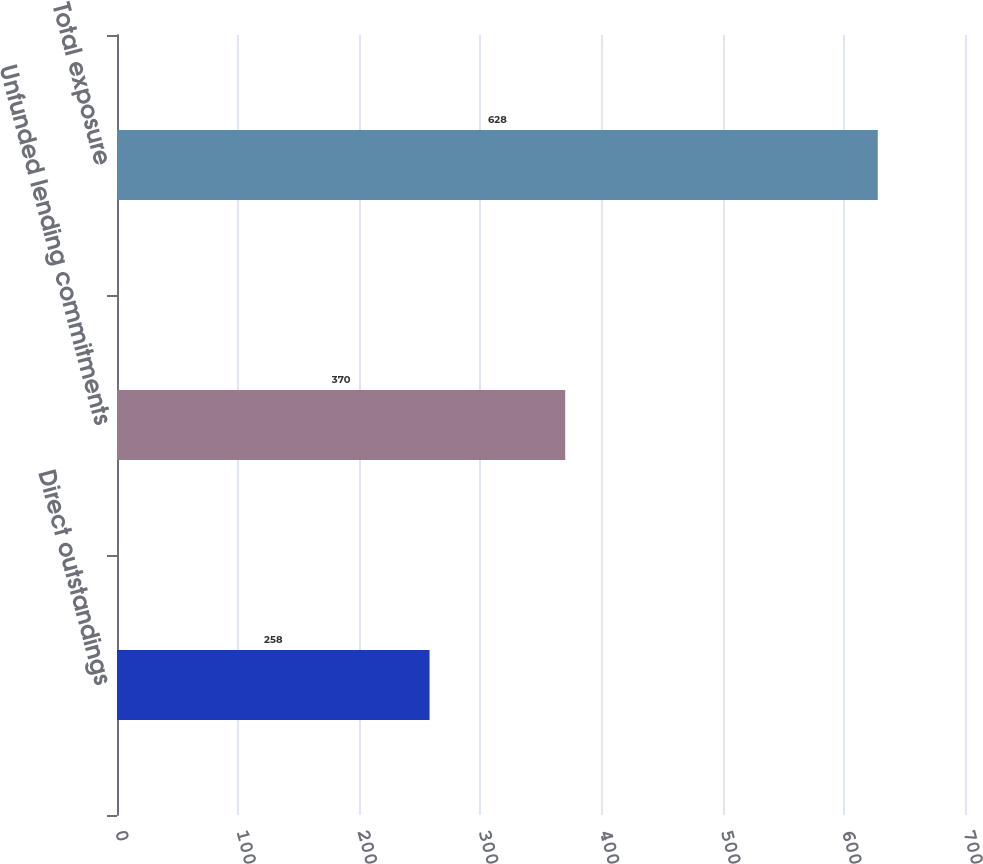Convert chart to OTSL. <chart><loc_0><loc_0><loc_500><loc_500><bar_chart><fcel>Direct outstandings<fcel>Unfunded lending commitments<fcel>Total exposure<nl><fcel>258<fcel>370<fcel>628<nl></chart> 